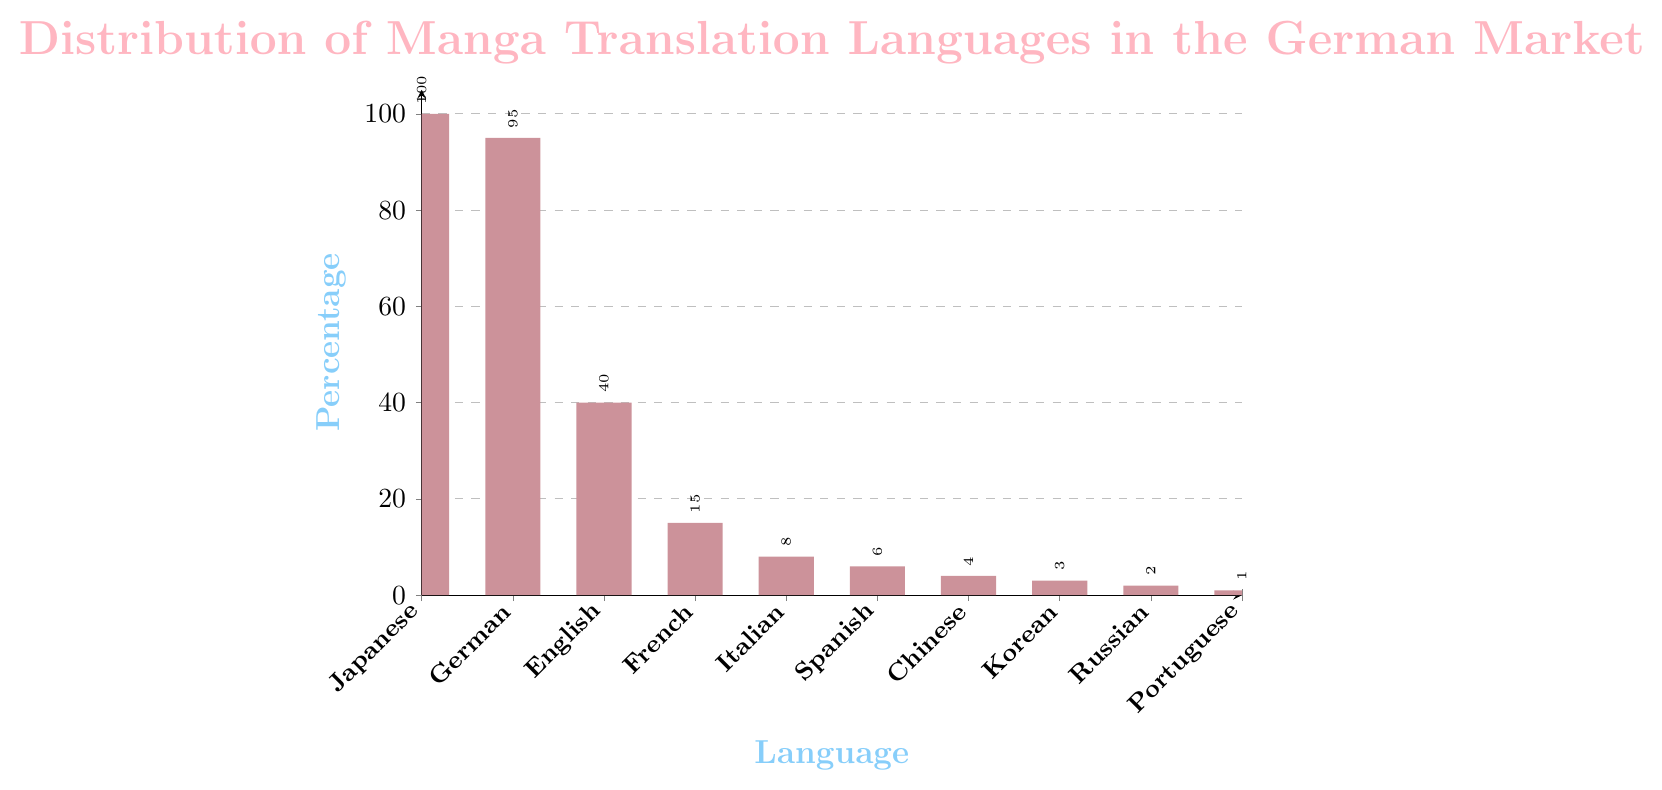Which language has the highest percentage of manga translations in the German market? The bar representing "Japanese" reaches the highest value on the percentage axis, which is 100%.
Answer: Japanese What is the difference in percentage between manga translations in German and English? The percentage for German is 95% and for English is 40%. The difference is 95% - 40% = 55%.
Answer: 55% Which languages have a percentage of manga translations less than 10%? The bars for Italian (8%), Spanish (6%), Chinese (4%), Korean (3%), Russian (2%), and Portuguese (1%) are all below the 10% mark on the percentage axis.
Answer: Italian, Spanish, Chinese, Korean, Russian, Portuguese Is the percentage of manga translations in French higher or lower than in Spanish? The bar for French translations is higher than the bar for Spanish translations. French is 15% and Spanish is 6%.
Answer: Higher Compare the total percentage of manga translations in French, Italian, and Spanish to the percentage of manga translations in English. Which is higher? Summing the percentages for French (15%), Italian (8%), and Spanish (6%) gives 15% + 8% + 6% = 29%. The English percentage is 40%, which is higher than 29%.
Answer: English What is the average percentage of manga translations in Chinese, Korean, and Russian? Adding the percentages of Chinese (4%), Korean (3%), and Russian (2%) gives 4% + 3% + 2% = 9%. The average is 9% / 3 = 3%.
Answer: 3% How many languages have a percentage of manga translations equal to or greater than 40%? The languages with 40% or more are Japanese (100%), German (95%), and English (40%). There are 3 such languages.
Answer: 3 By how much does the percentage of Portuguese manga translations fall short of the percentage for Korean manga translations? The percentage for Portuguese is 1% and for Korean is 3%. The difference is 3% - 1% = 2%.
Answer: 2% 